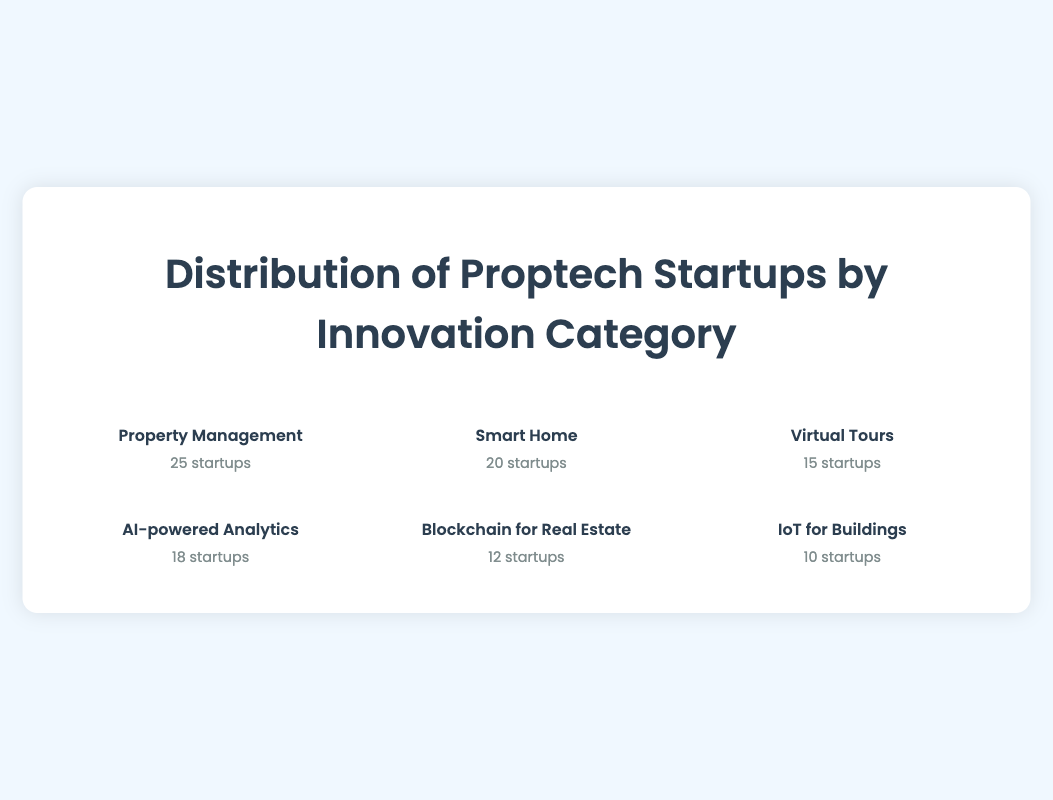What is the category with the highest number of proptech startups? The figure shows icons representing different categories of proptech startups. Counting the number of icons in each category reveals that "Property Management" has 25 startups, which is the highest.
Answer: Property Management Which category has the fewest proptech startups? By examining the figure, there are only 10 icons under the "IoT for Buildings" category, making it the category with the fewest startups.
Answer: IoT for Buildings What is the total number of proptech startups across all categories? Adding the counts of startups for each category: 25 (Property Management) + 20 (Smart Home) + 15 (Virtual Tours) + 18 (AI-powered Analytics) + 12 (Blockchain for Real Estate) + 10 (IoT for Buildings) = 100 startups.
Answer: 100 How does the number of startups in the "AI-powered Analytics" category compare to the "Smart Home" category? The "AI-powered Analytics" category has 18 startups, while the "Smart Home" category has 20 startups. Comparing the two, the "AI-powered Analytics" category has 2 fewer startups than the "Smart Home" category.
Answer: 2 fewer Which category has exactly 15 startups? By looking at the counts of startups in each category, "Virtual Tours" has exactly 15 startups.
Answer: Virtual Tours How many more startups are in the "Property Management" category compared to "IoT for Buildings"? The "Property Management" category has 25 startups and "IoT for Buildings" has 10 startups. The difference is 25 - 10 = 15 startups.
Answer: 15 more Which categories have more than 15 startups? The categories with more than 15 startups are "Property Management" (25 startups), "Smart Home" (20 startups), and "AI-powered Analytics" (18 startups).
Answer: Property Management, Smart Home, AI-powered Analytics What percentage of the total startups does the "Blockchain for Real Estate" category represent? There are 12 startups in the "Blockchain for Real Estate" category out of 100 total startups. The percentage is (12/100) * 100% = 12%.
Answer: 12% What is the average number of startups per category? There are 6 categories with a total of 100 startups. The average number of startups per category is 100 / 6 ≈ 16.67.
Answer: 16.67 If the count of "Smart Home" startups doubles, what would be the new total number of proptech startups? Doubling the "Smart Home" count gives 20 * 2 = 40. Adding this to the other categories: 25 (Property Management) + 40 (Smart Home) + 15 (Virtual Tours) + 18 (AI-powered Analytics) + 12 (Blockchain for Real Estate) + 10 (IoT for Buildings) = 120 startups.
Answer: 120 